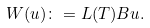<formula> <loc_0><loc_0><loc_500><loc_500>W ( u ) \colon = L ( T ) B u .</formula> 